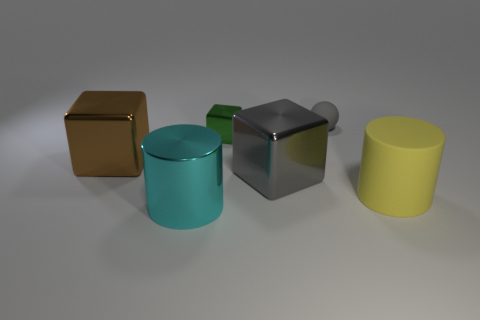Subtract all big metal blocks. How many blocks are left? 1 Add 3 yellow objects. How many objects exist? 9 Subtract all yellow cylinders. How many cylinders are left? 1 Subtract 2 blocks. How many blocks are left? 1 Subtract all cylinders. How many objects are left? 4 Subtract all small red metal spheres. Subtract all small balls. How many objects are left? 5 Add 6 big gray objects. How many big gray objects are left? 7 Add 4 small rubber things. How many small rubber things exist? 5 Subtract 0 yellow cubes. How many objects are left? 6 Subtract all yellow spheres. Subtract all gray cylinders. How many spheres are left? 1 